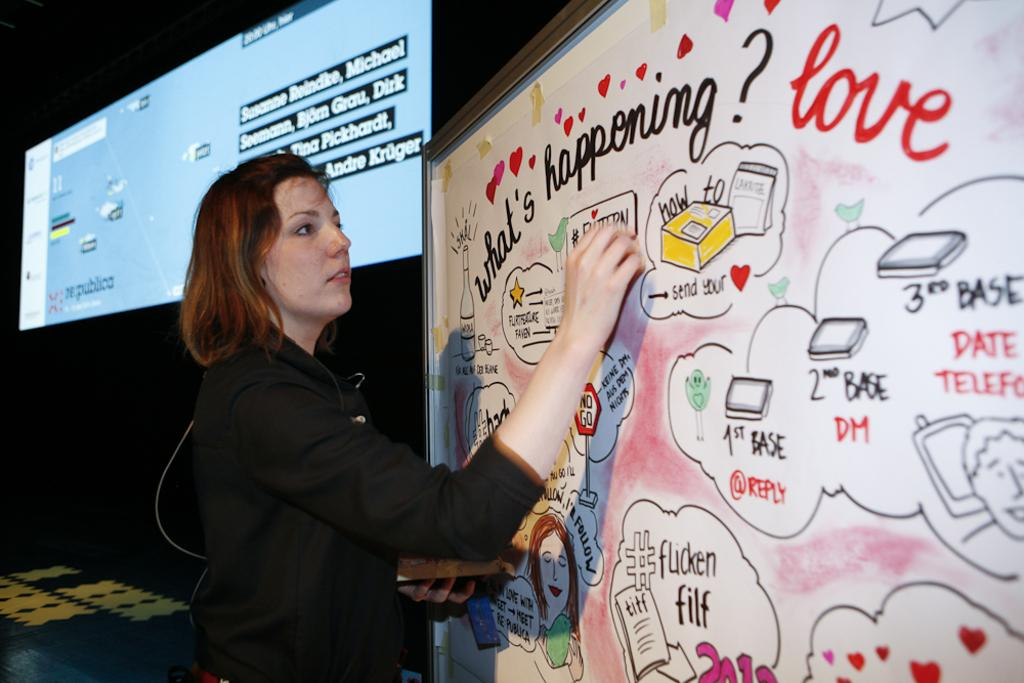Provide a one-sentence caption for the provided image. A woman is writing on a white board that has hearts and an overall theme of love written on it. 